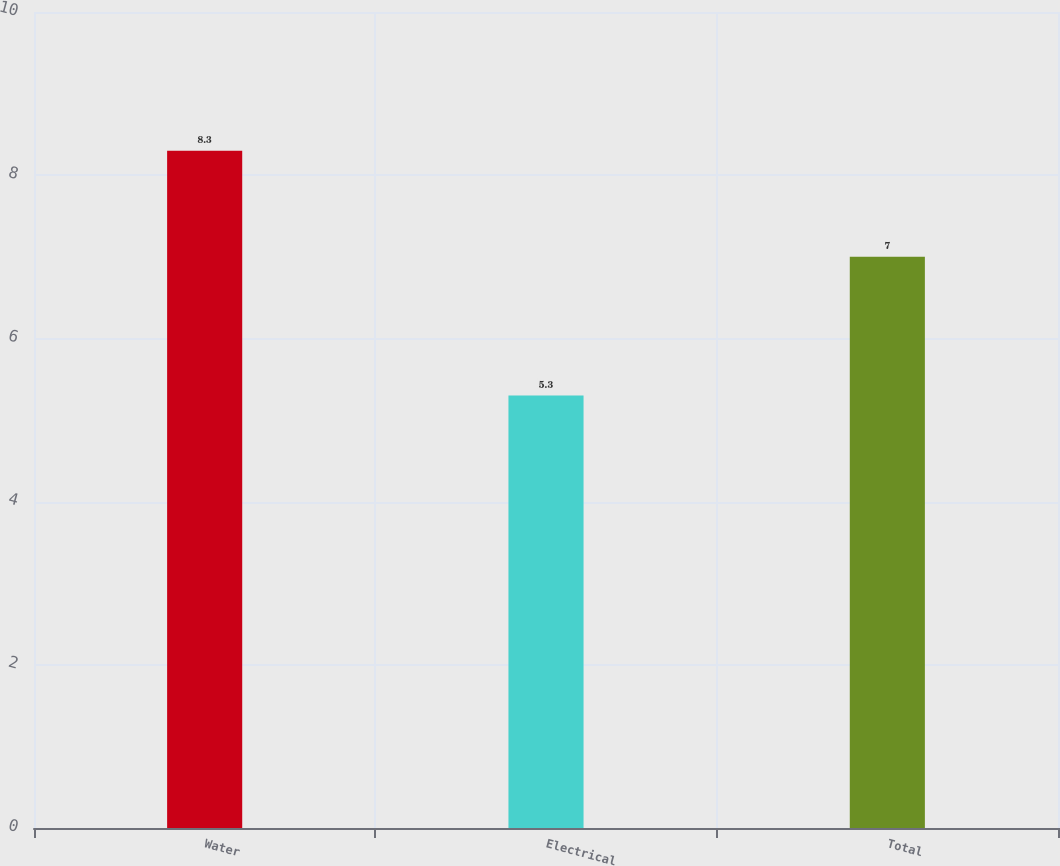Convert chart. <chart><loc_0><loc_0><loc_500><loc_500><bar_chart><fcel>Water<fcel>Electrical<fcel>Total<nl><fcel>8.3<fcel>5.3<fcel>7<nl></chart> 